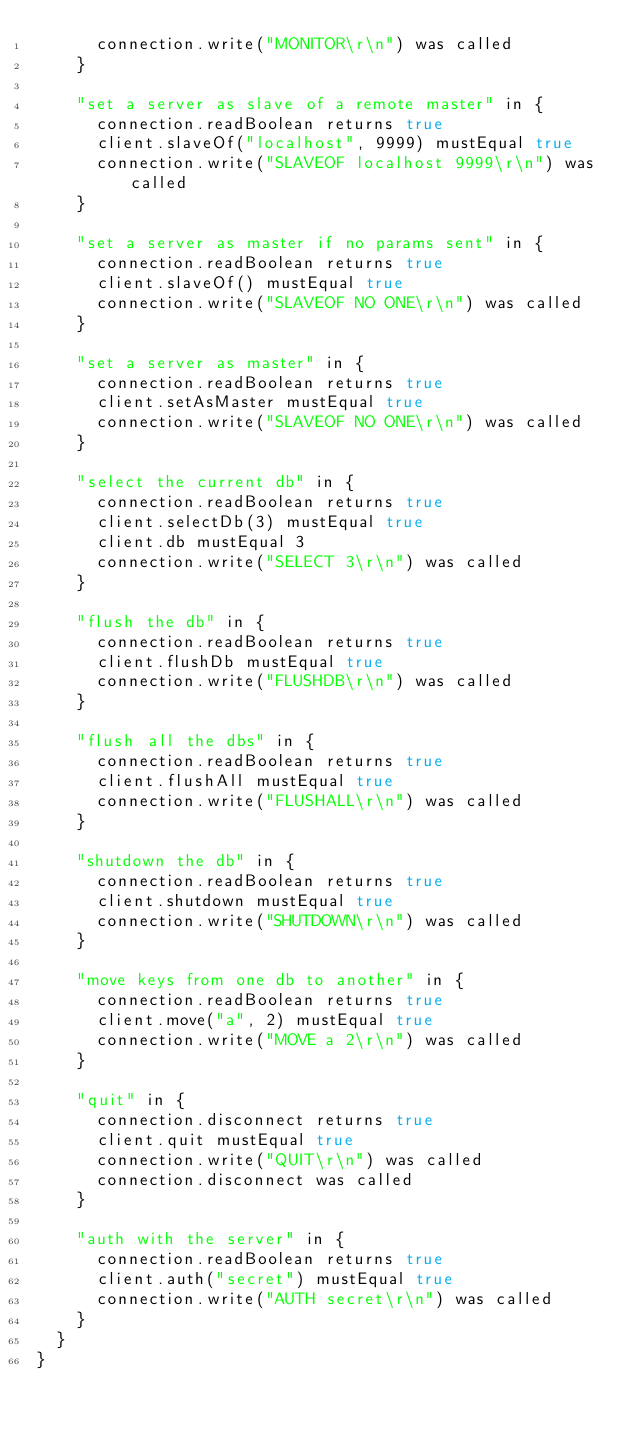Convert code to text. <code><loc_0><loc_0><loc_500><loc_500><_Scala_>      connection.write("MONITOR\r\n") was called
    }
    
    "set a server as slave of a remote master" in {
      connection.readBoolean returns true
      client.slaveOf("localhost", 9999) mustEqual true
      connection.write("SLAVEOF localhost 9999\r\n") was called
    }
    
    "set a server as master if no params sent" in {
      connection.readBoolean returns true
      client.slaveOf() mustEqual true
      connection.write("SLAVEOF NO ONE\r\n") was called
    }
    
    "set a server as master" in {
      connection.readBoolean returns true
      client.setAsMaster mustEqual true
      connection.write("SLAVEOF NO ONE\r\n") was called
    }
    
    "select the current db" in {
      connection.readBoolean returns true
      client.selectDb(3) mustEqual true
      client.db mustEqual 3
      connection.write("SELECT 3\r\n") was called
    }
    
    "flush the db" in {
      connection.readBoolean returns true
      client.flushDb mustEqual true
      connection.write("FLUSHDB\r\n") was called
    }
    
    "flush all the dbs" in {
      connection.readBoolean returns true
      client.flushAll mustEqual true
      connection.write("FLUSHALL\r\n") was called
    }
    
    "shutdown the db" in {
      connection.readBoolean returns true
      client.shutdown mustEqual true
      connection.write("SHUTDOWN\r\n") was called
    }
    
    "move keys from one db to another" in {
      connection.readBoolean returns true
      client.move("a", 2) mustEqual true
      connection.write("MOVE a 2\r\n") was called
    }
    
    "quit" in {
      connection.disconnect returns true
      client.quit mustEqual true
      connection.write("QUIT\r\n") was called
      connection.disconnect was called
    }
    
    "auth with the server" in {
      connection.readBoolean returns true
      client.auth("secret") mustEqual true
      connection.write("AUTH secret\r\n") was called
    }
  }
}
</code> 